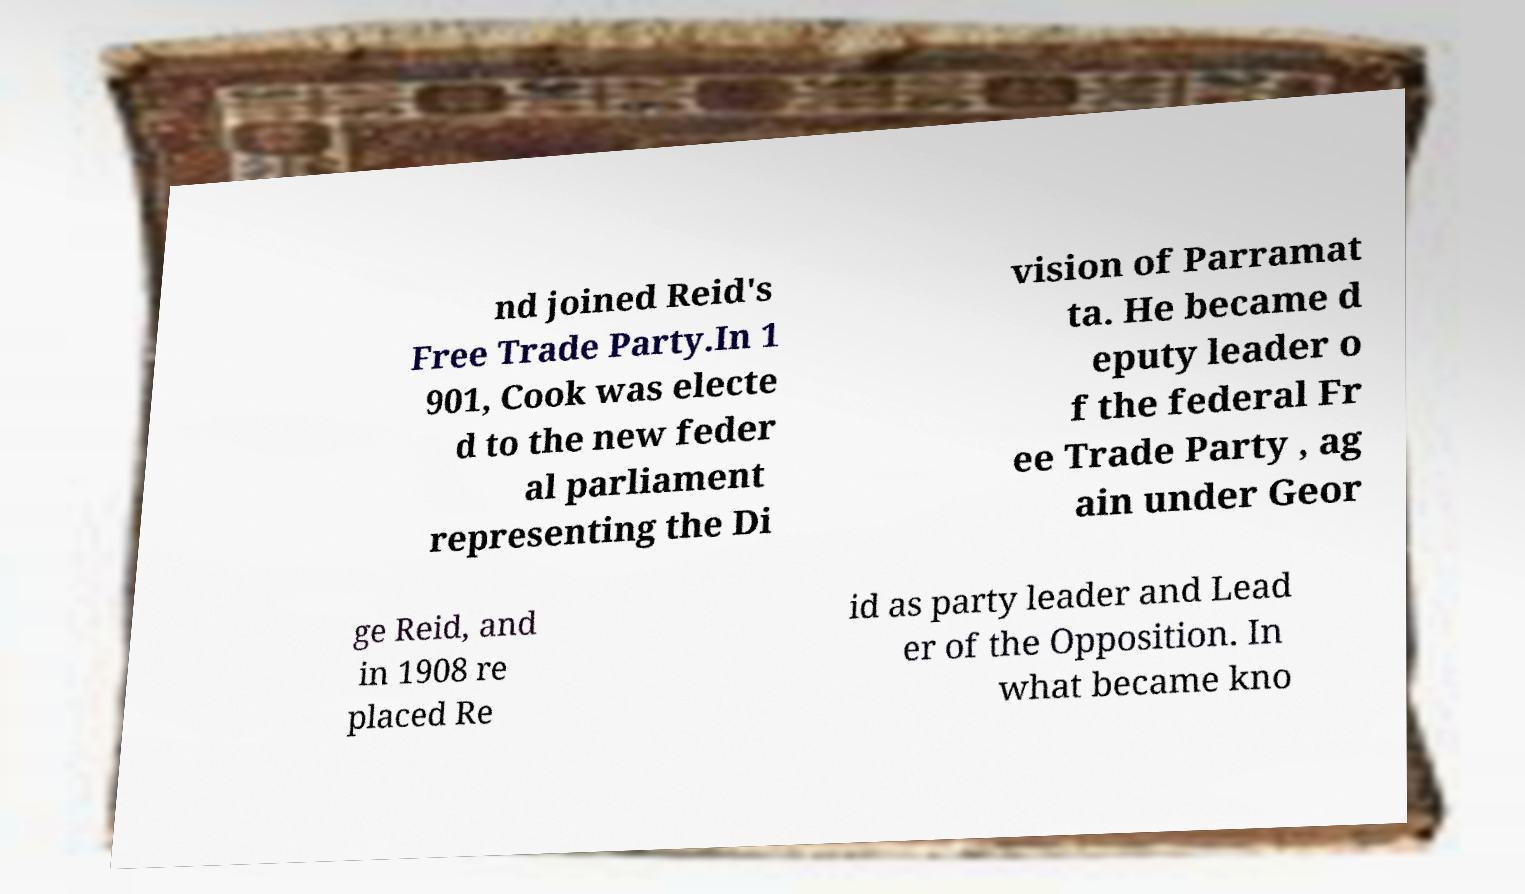For documentation purposes, I need the text within this image transcribed. Could you provide that? nd joined Reid's Free Trade Party.In 1 901, Cook was electe d to the new feder al parliament representing the Di vision of Parramat ta. He became d eputy leader o f the federal Fr ee Trade Party , ag ain under Geor ge Reid, and in 1908 re placed Re id as party leader and Lead er of the Opposition. In what became kno 